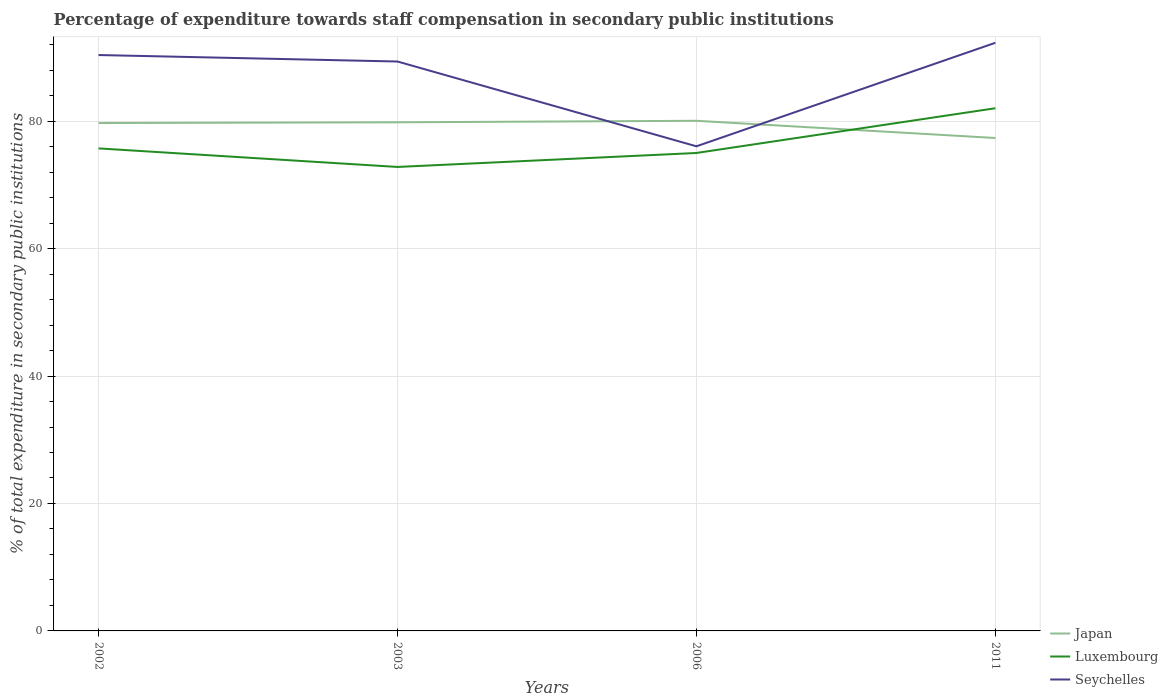How many different coloured lines are there?
Give a very brief answer. 3. Is the number of lines equal to the number of legend labels?
Your response must be concise. Yes. Across all years, what is the maximum percentage of expenditure towards staff compensation in Seychelles?
Provide a short and direct response. 76.06. What is the total percentage of expenditure towards staff compensation in Japan in the graph?
Ensure brevity in your answer.  2.7. What is the difference between the highest and the second highest percentage of expenditure towards staff compensation in Luxembourg?
Keep it short and to the point. 9.21. What is the difference between the highest and the lowest percentage of expenditure towards staff compensation in Japan?
Offer a very short reply. 3. Is the percentage of expenditure towards staff compensation in Japan strictly greater than the percentage of expenditure towards staff compensation in Seychelles over the years?
Provide a succinct answer. No. How many lines are there?
Your answer should be very brief. 3. How many years are there in the graph?
Offer a very short reply. 4. What is the difference between two consecutive major ticks on the Y-axis?
Offer a very short reply. 20. Does the graph contain any zero values?
Offer a very short reply. No. Where does the legend appear in the graph?
Your answer should be very brief. Bottom right. How are the legend labels stacked?
Your response must be concise. Vertical. What is the title of the graph?
Keep it short and to the point. Percentage of expenditure towards staff compensation in secondary public institutions. Does "South Asia" appear as one of the legend labels in the graph?
Your answer should be compact. No. What is the label or title of the Y-axis?
Your response must be concise. % of total expenditure in secondary public institutions. What is the % of total expenditure in secondary public institutions of Japan in 2002?
Ensure brevity in your answer.  79.71. What is the % of total expenditure in secondary public institutions in Luxembourg in 2002?
Your answer should be very brief. 75.73. What is the % of total expenditure in secondary public institutions of Seychelles in 2002?
Provide a succinct answer. 90.38. What is the % of total expenditure in secondary public institutions in Japan in 2003?
Offer a terse response. 79.82. What is the % of total expenditure in secondary public institutions in Luxembourg in 2003?
Your answer should be very brief. 72.81. What is the % of total expenditure in secondary public institutions of Seychelles in 2003?
Your answer should be very brief. 89.36. What is the % of total expenditure in secondary public institutions in Japan in 2006?
Make the answer very short. 80.06. What is the % of total expenditure in secondary public institutions of Luxembourg in 2006?
Give a very brief answer. 75.01. What is the % of total expenditure in secondary public institutions of Seychelles in 2006?
Your response must be concise. 76.06. What is the % of total expenditure in secondary public institutions in Japan in 2011?
Ensure brevity in your answer.  77.36. What is the % of total expenditure in secondary public institutions of Luxembourg in 2011?
Provide a succinct answer. 82.03. What is the % of total expenditure in secondary public institutions in Seychelles in 2011?
Offer a terse response. 92.3. Across all years, what is the maximum % of total expenditure in secondary public institutions of Japan?
Provide a succinct answer. 80.06. Across all years, what is the maximum % of total expenditure in secondary public institutions of Luxembourg?
Provide a succinct answer. 82.03. Across all years, what is the maximum % of total expenditure in secondary public institutions in Seychelles?
Provide a succinct answer. 92.3. Across all years, what is the minimum % of total expenditure in secondary public institutions in Japan?
Your answer should be compact. 77.36. Across all years, what is the minimum % of total expenditure in secondary public institutions of Luxembourg?
Offer a terse response. 72.81. Across all years, what is the minimum % of total expenditure in secondary public institutions of Seychelles?
Offer a very short reply. 76.06. What is the total % of total expenditure in secondary public institutions in Japan in the graph?
Your answer should be compact. 316.95. What is the total % of total expenditure in secondary public institutions in Luxembourg in the graph?
Give a very brief answer. 305.58. What is the total % of total expenditure in secondary public institutions of Seychelles in the graph?
Provide a succinct answer. 348.1. What is the difference between the % of total expenditure in secondary public institutions in Japan in 2002 and that in 2003?
Offer a terse response. -0.11. What is the difference between the % of total expenditure in secondary public institutions of Luxembourg in 2002 and that in 2003?
Offer a terse response. 2.91. What is the difference between the % of total expenditure in secondary public institutions of Seychelles in 2002 and that in 2003?
Give a very brief answer. 1.02. What is the difference between the % of total expenditure in secondary public institutions of Japan in 2002 and that in 2006?
Offer a terse response. -0.35. What is the difference between the % of total expenditure in secondary public institutions of Luxembourg in 2002 and that in 2006?
Offer a very short reply. 0.72. What is the difference between the % of total expenditure in secondary public institutions of Seychelles in 2002 and that in 2006?
Provide a short and direct response. 14.33. What is the difference between the % of total expenditure in secondary public institutions of Japan in 2002 and that in 2011?
Offer a terse response. 2.35. What is the difference between the % of total expenditure in secondary public institutions in Luxembourg in 2002 and that in 2011?
Give a very brief answer. -6.3. What is the difference between the % of total expenditure in secondary public institutions in Seychelles in 2002 and that in 2011?
Make the answer very short. -1.92. What is the difference between the % of total expenditure in secondary public institutions in Japan in 2003 and that in 2006?
Ensure brevity in your answer.  -0.24. What is the difference between the % of total expenditure in secondary public institutions in Luxembourg in 2003 and that in 2006?
Your response must be concise. -2.19. What is the difference between the % of total expenditure in secondary public institutions in Seychelles in 2003 and that in 2006?
Ensure brevity in your answer.  13.31. What is the difference between the % of total expenditure in secondary public institutions in Japan in 2003 and that in 2011?
Ensure brevity in your answer.  2.46. What is the difference between the % of total expenditure in secondary public institutions in Luxembourg in 2003 and that in 2011?
Provide a succinct answer. -9.21. What is the difference between the % of total expenditure in secondary public institutions of Seychelles in 2003 and that in 2011?
Provide a short and direct response. -2.94. What is the difference between the % of total expenditure in secondary public institutions of Japan in 2006 and that in 2011?
Your answer should be very brief. 2.7. What is the difference between the % of total expenditure in secondary public institutions of Luxembourg in 2006 and that in 2011?
Your response must be concise. -7.02. What is the difference between the % of total expenditure in secondary public institutions in Seychelles in 2006 and that in 2011?
Provide a short and direct response. -16.25. What is the difference between the % of total expenditure in secondary public institutions of Japan in 2002 and the % of total expenditure in secondary public institutions of Luxembourg in 2003?
Offer a terse response. 6.89. What is the difference between the % of total expenditure in secondary public institutions in Japan in 2002 and the % of total expenditure in secondary public institutions in Seychelles in 2003?
Give a very brief answer. -9.65. What is the difference between the % of total expenditure in secondary public institutions in Luxembourg in 2002 and the % of total expenditure in secondary public institutions in Seychelles in 2003?
Your answer should be very brief. -13.64. What is the difference between the % of total expenditure in secondary public institutions of Japan in 2002 and the % of total expenditure in secondary public institutions of Luxembourg in 2006?
Offer a very short reply. 4.7. What is the difference between the % of total expenditure in secondary public institutions in Japan in 2002 and the % of total expenditure in secondary public institutions in Seychelles in 2006?
Make the answer very short. 3.65. What is the difference between the % of total expenditure in secondary public institutions in Luxembourg in 2002 and the % of total expenditure in secondary public institutions in Seychelles in 2006?
Offer a very short reply. -0.33. What is the difference between the % of total expenditure in secondary public institutions of Japan in 2002 and the % of total expenditure in secondary public institutions of Luxembourg in 2011?
Your answer should be very brief. -2.32. What is the difference between the % of total expenditure in secondary public institutions of Japan in 2002 and the % of total expenditure in secondary public institutions of Seychelles in 2011?
Ensure brevity in your answer.  -12.59. What is the difference between the % of total expenditure in secondary public institutions of Luxembourg in 2002 and the % of total expenditure in secondary public institutions of Seychelles in 2011?
Keep it short and to the point. -16.57. What is the difference between the % of total expenditure in secondary public institutions of Japan in 2003 and the % of total expenditure in secondary public institutions of Luxembourg in 2006?
Your answer should be very brief. 4.82. What is the difference between the % of total expenditure in secondary public institutions in Japan in 2003 and the % of total expenditure in secondary public institutions in Seychelles in 2006?
Offer a terse response. 3.77. What is the difference between the % of total expenditure in secondary public institutions of Luxembourg in 2003 and the % of total expenditure in secondary public institutions of Seychelles in 2006?
Give a very brief answer. -3.24. What is the difference between the % of total expenditure in secondary public institutions in Japan in 2003 and the % of total expenditure in secondary public institutions in Luxembourg in 2011?
Ensure brevity in your answer.  -2.21. What is the difference between the % of total expenditure in secondary public institutions of Japan in 2003 and the % of total expenditure in secondary public institutions of Seychelles in 2011?
Give a very brief answer. -12.48. What is the difference between the % of total expenditure in secondary public institutions of Luxembourg in 2003 and the % of total expenditure in secondary public institutions of Seychelles in 2011?
Provide a short and direct response. -19.49. What is the difference between the % of total expenditure in secondary public institutions in Japan in 2006 and the % of total expenditure in secondary public institutions in Luxembourg in 2011?
Your answer should be compact. -1.97. What is the difference between the % of total expenditure in secondary public institutions of Japan in 2006 and the % of total expenditure in secondary public institutions of Seychelles in 2011?
Offer a very short reply. -12.24. What is the difference between the % of total expenditure in secondary public institutions of Luxembourg in 2006 and the % of total expenditure in secondary public institutions of Seychelles in 2011?
Your answer should be compact. -17.29. What is the average % of total expenditure in secondary public institutions in Japan per year?
Your response must be concise. 79.24. What is the average % of total expenditure in secondary public institutions of Luxembourg per year?
Your answer should be very brief. 76.39. What is the average % of total expenditure in secondary public institutions of Seychelles per year?
Your answer should be very brief. 87.02. In the year 2002, what is the difference between the % of total expenditure in secondary public institutions in Japan and % of total expenditure in secondary public institutions in Luxembourg?
Offer a terse response. 3.98. In the year 2002, what is the difference between the % of total expenditure in secondary public institutions in Japan and % of total expenditure in secondary public institutions in Seychelles?
Your answer should be compact. -10.67. In the year 2002, what is the difference between the % of total expenditure in secondary public institutions in Luxembourg and % of total expenditure in secondary public institutions in Seychelles?
Offer a very short reply. -14.65. In the year 2003, what is the difference between the % of total expenditure in secondary public institutions of Japan and % of total expenditure in secondary public institutions of Luxembourg?
Offer a very short reply. 7.01. In the year 2003, what is the difference between the % of total expenditure in secondary public institutions of Japan and % of total expenditure in secondary public institutions of Seychelles?
Provide a succinct answer. -9.54. In the year 2003, what is the difference between the % of total expenditure in secondary public institutions of Luxembourg and % of total expenditure in secondary public institutions of Seychelles?
Keep it short and to the point. -16.55. In the year 2006, what is the difference between the % of total expenditure in secondary public institutions in Japan and % of total expenditure in secondary public institutions in Luxembourg?
Ensure brevity in your answer.  5.05. In the year 2006, what is the difference between the % of total expenditure in secondary public institutions in Japan and % of total expenditure in secondary public institutions in Seychelles?
Ensure brevity in your answer.  4. In the year 2006, what is the difference between the % of total expenditure in secondary public institutions in Luxembourg and % of total expenditure in secondary public institutions in Seychelles?
Your response must be concise. -1.05. In the year 2011, what is the difference between the % of total expenditure in secondary public institutions in Japan and % of total expenditure in secondary public institutions in Luxembourg?
Ensure brevity in your answer.  -4.67. In the year 2011, what is the difference between the % of total expenditure in secondary public institutions in Japan and % of total expenditure in secondary public institutions in Seychelles?
Your answer should be compact. -14.94. In the year 2011, what is the difference between the % of total expenditure in secondary public institutions of Luxembourg and % of total expenditure in secondary public institutions of Seychelles?
Your answer should be very brief. -10.27. What is the ratio of the % of total expenditure in secondary public institutions in Seychelles in 2002 to that in 2003?
Make the answer very short. 1.01. What is the ratio of the % of total expenditure in secondary public institutions of Luxembourg in 2002 to that in 2006?
Your answer should be compact. 1.01. What is the ratio of the % of total expenditure in secondary public institutions in Seychelles in 2002 to that in 2006?
Make the answer very short. 1.19. What is the ratio of the % of total expenditure in secondary public institutions of Japan in 2002 to that in 2011?
Provide a short and direct response. 1.03. What is the ratio of the % of total expenditure in secondary public institutions of Luxembourg in 2002 to that in 2011?
Offer a very short reply. 0.92. What is the ratio of the % of total expenditure in secondary public institutions in Seychelles in 2002 to that in 2011?
Provide a succinct answer. 0.98. What is the ratio of the % of total expenditure in secondary public institutions in Luxembourg in 2003 to that in 2006?
Your answer should be compact. 0.97. What is the ratio of the % of total expenditure in secondary public institutions in Seychelles in 2003 to that in 2006?
Your response must be concise. 1.18. What is the ratio of the % of total expenditure in secondary public institutions in Japan in 2003 to that in 2011?
Offer a very short reply. 1.03. What is the ratio of the % of total expenditure in secondary public institutions in Luxembourg in 2003 to that in 2011?
Give a very brief answer. 0.89. What is the ratio of the % of total expenditure in secondary public institutions in Seychelles in 2003 to that in 2011?
Keep it short and to the point. 0.97. What is the ratio of the % of total expenditure in secondary public institutions in Japan in 2006 to that in 2011?
Your response must be concise. 1.03. What is the ratio of the % of total expenditure in secondary public institutions of Luxembourg in 2006 to that in 2011?
Offer a terse response. 0.91. What is the ratio of the % of total expenditure in secondary public institutions in Seychelles in 2006 to that in 2011?
Give a very brief answer. 0.82. What is the difference between the highest and the second highest % of total expenditure in secondary public institutions in Japan?
Ensure brevity in your answer.  0.24. What is the difference between the highest and the second highest % of total expenditure in secondary public institutions of Luxembourg?
Your response must be concise. 6.3. What is the difference between the highest and the second highest % of total expenditure in secondary public institutions of Seychelles?
Your response must be concise. 1.92. What is the difference between the highest and the lowest % of total expenditure in secondary public institutions in Japan?
Make the answer very short. 2.7. What is the difference between the highest and the lowest % of total expenditure in secondary public institutions in Luxembourg?
Your answer should be compact. 9.21. What is the difference between the highest and the lowest % of total expenditure in secondary public institutions in Seychelles?
Make the answer very short. 16.25. 